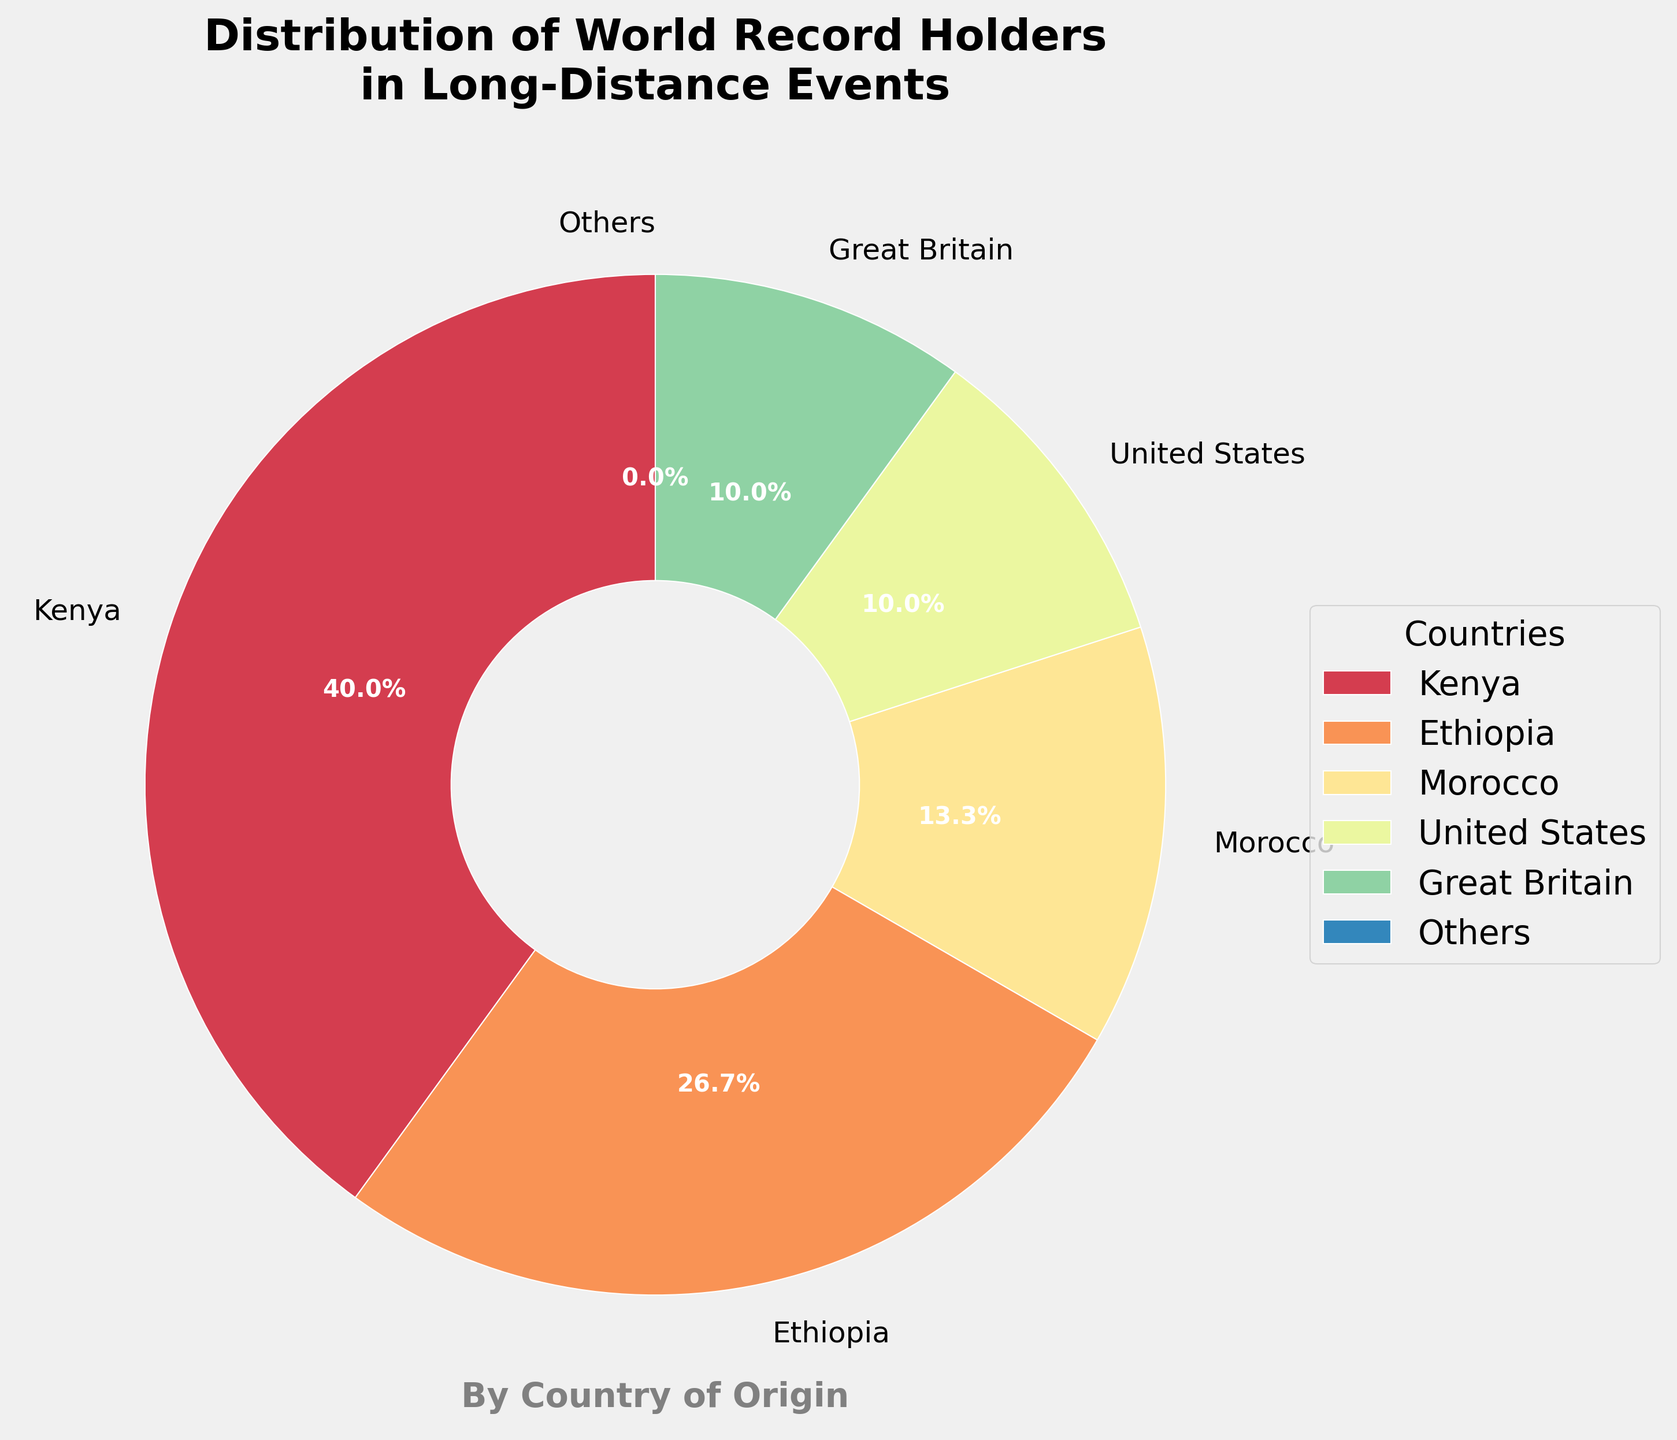What country has the largest percentage of world record holders in long-distance events? The largest wedge on the pie chart corresponds to Kenya. The label on this wedge shows 12 world record holders, which is the highest count.
Answer: Kenya How does the percentage of record holders from Ethiopia compare to that of the United States? The wedge for Ethiopia shows 8 world record holders, while the United States has 3. Visually, Ethiopia's wedge is larger than that of the United States, and the percentages reflect this difference.
Answer: Ethiopia has a higher percentage than the United States What is the total percentage of world record holders from Kenya, Ethiopia, and Morocco combined? Kenya has 12, Ethiopia has 8, and Morocco has 4 record holders. Adding these gives a total of 24. The pie chart represents these categories individually, showing their respective percentages. Adding the percentages: 40% (Kenya) + 26.7% (Ethiopia) + 13.3% (Morocco) = 80%.
Answer: 80% How many countries have 3 or more world record holders? The pie chart includes wedges for Kenya, Ethiopia, Morocco, United States, and Great Britain—each with 3 or more record holders. Counting these gives 5 countries.
Answer: 5 Which country has a smaller percentage of world record holders than Great Britain but more than Poland? Great Britain has a wedge that shows 3 record holders, while Poland's wedge represents only 1 record holder. The country with more than 1 but fewer than 3 record holders on the pie chart is Uganda, China, and Japan, each with 2.
Answer: Uganda, China, Japan What is the combined number of world record holders for the countries categorized as "Others"? The "Others" category includes countries with individual counts less than 3. Visually summing these wedges, it appears to include Uganda (2), China (2), Japan (2), Norway (1), Poland (1), Eritrea (1), and Netherlands (1). Adding these values gives 10.
Answer: 10 Considering the visual color spectrum, which country is represented by the most prominent slice color? The most prominent and largest slice in the pie chart corresponds to Kenya. The color associated with this slice is a shade of color used in the color map.
Answer: Kenya 